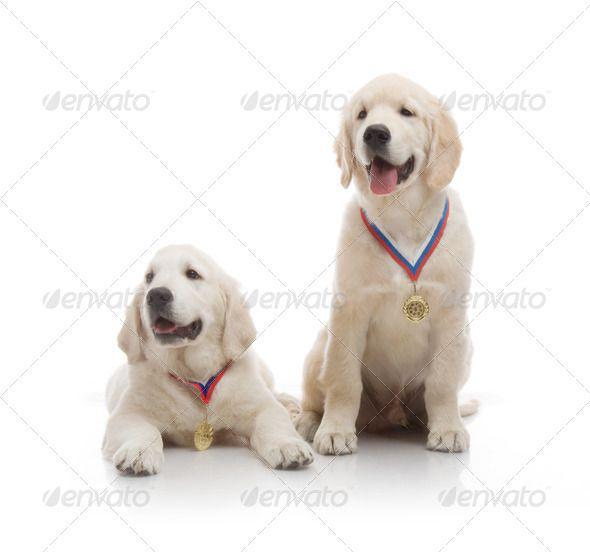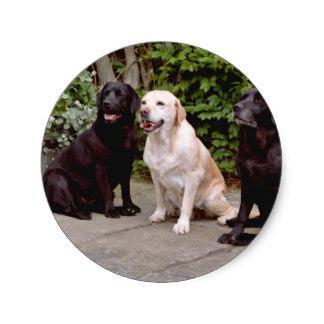The first image is the image on the left, the second image is the image on the right. For the images displayed, is the sentence "There are exactly four dogs." factually correct? Answer yes or no. No. The first image is the image on the left, the second image is the image on the right. Analyze the images presented: Is the assertion "There are exactly four dogs in total." valid? Answer yes or no. No. 